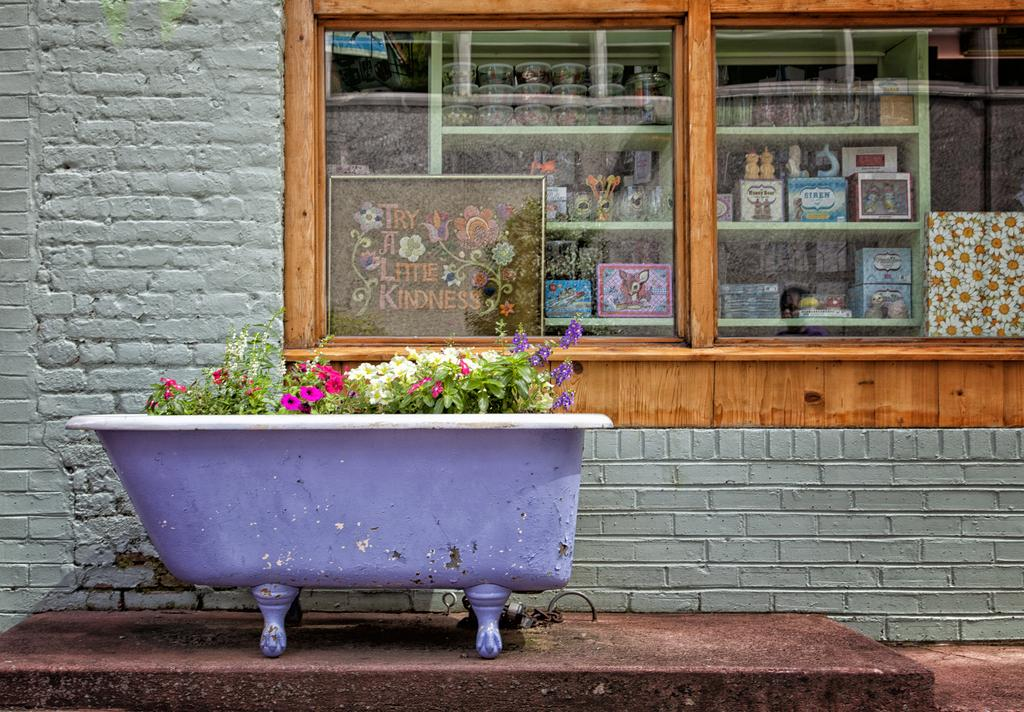What can be found in the flower pot in the image? The flower pot has flowers in it. What type of structure is visible in the image? There is a wall in the image. Is there any opening in the wall visible in the image? Yes, there is a window in the image. What can be seen on the shelf in the image? There are objects placed on a shelf in the image. How does the honey flow in the image? There is no honey present in the image. What is the cent used for in the image? There is no cent present in the image. 